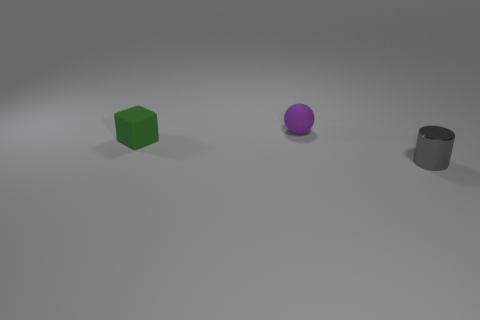Add 1 gray metallic cylinders. How many objects exist? 4 Subtract all cubes. How many objects are left? 2 Subtract 1 cylinders. How many cylinders are left? 0 Subtract all big red matte cylinders. Subtract all tiny cylinders. How many objects are left? 2 Add 1 gray cylinders. How many gray cylinders are left? 2 Add 1 tiny purple rubber balls. How many tiny purple rubber balls exist? 2 Subtract 0 cyan cubes. How many objects are left? 3 Subtract all yellow spheres. Subtract all yellow blocks. How many spheres are left? 1 